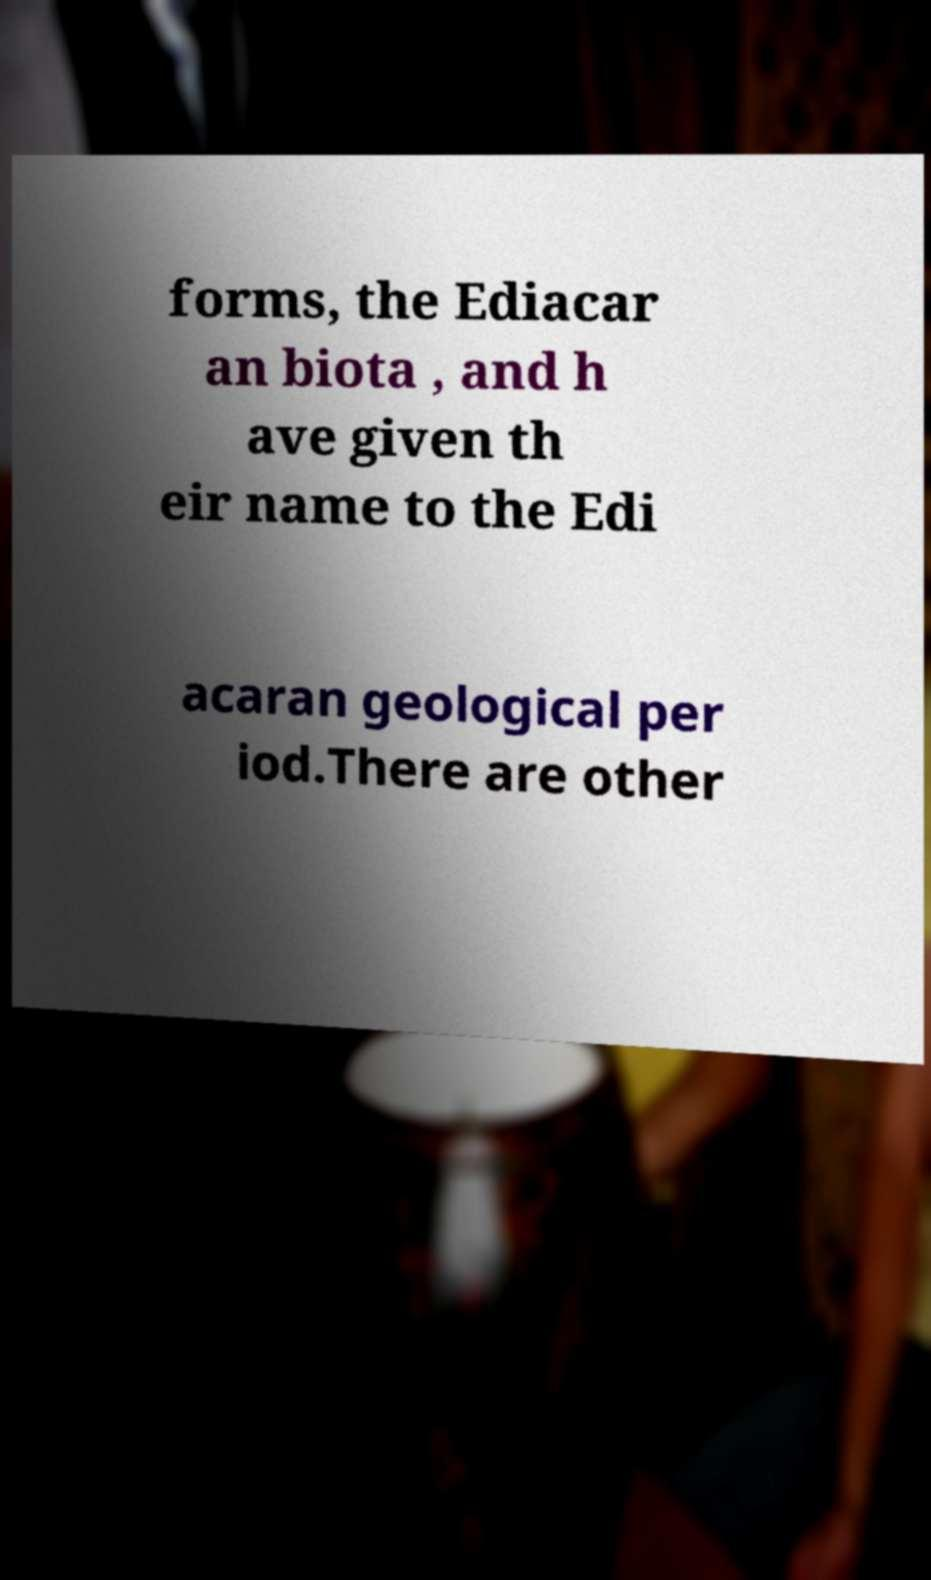Please read and relay the text visible in this image. What does it say? forms, the Ediacar an biota , and h ave given th eir name to the Edi acaran geological per iod.There are other 